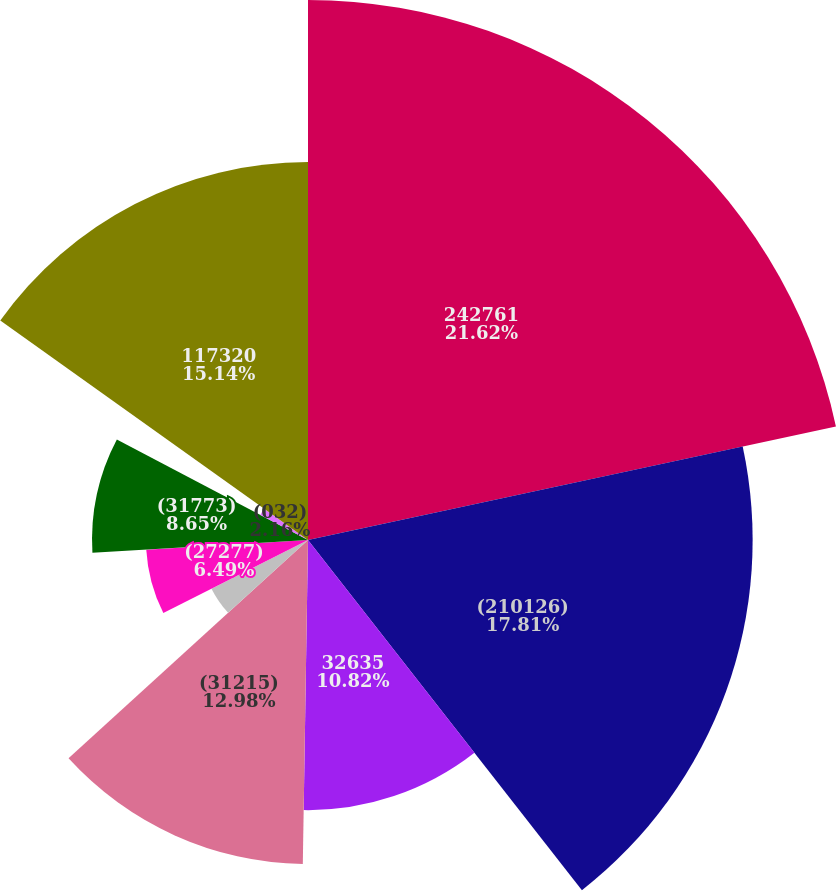Convert chart to OTSL. <chart><loc_0><loc_0><loc_500><loc_500><pie_chart><fcel>242761<fcel>(210126)<fcel>32635<fcel>(31215)<fcel>3938<fcel>(27277)<fcel>(31773)<fcel>(032)<fcel>(027)<fcel>117320<nl><fcel>21.63%<fcel>17.81%<fcel>10.82%<fcel>12.98%<fcel>4.33%<fcel>6.49%<fcel>8.65%<fcel>2.16%<fcel>0.0%<fcel>15.14%<nl></chart> 